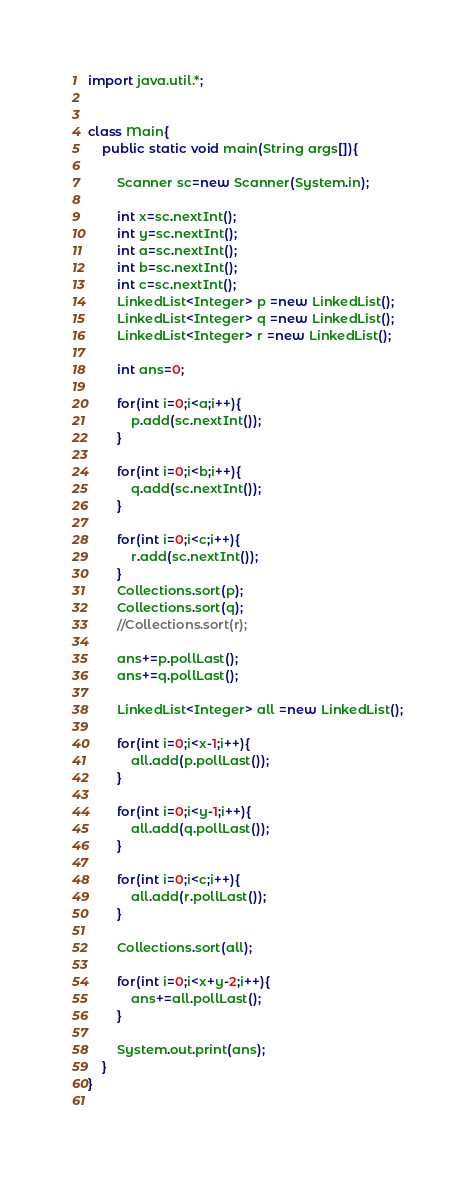<code> <loc_0><loc_0><loc_500><loc_500><_Java_>import java.util.*;


class Main{
	public static void main(String args[]){
		
		Scanner sc=new Scanner(System.in);
		
		int x=sc.nextInt();
		int y=sc.nextInt();
		int a=sc.nextInt();
		int b=sc.nextInt();
		int c=sc.nextInt();
		LinkedList<Integer> p =new LinkedList();
		LinkedList<Integer> q =new LinkedList();
		LinkedList<Integer> r =new LinkedList();
		
		int ans=0;
		
		for(int i=0;i<a;i++){
			p.add(sc.nextInt());
		}
		
		for(int i=0;i<b;i++){
			q.add(sc.nextInt());
		}
		
		for(int i=0;i<c;i++){
			r.add(sc.nextInt());
		}
		Collections.sort(p);
		Collections.sort(q);
		//Collections.sort(r);
		
		ans+=p.pollLast();
		ans+=q.pollLast();
		
		LinkedList<Integer> all =new LinkedList();
		
		for(int i=0;i<x-1;i++){
			all.add(p.pollLast());
		}
		
		for(int i=0;i<y-1;i++){
			all.add(q.pollLast());
		}
		
		for(int i=0;i<c;i++){
			all.add(r.pollLast());
		}
		
		Collections.sort(all);
		
		for(int i=0;i<x+y-2;i++){
			ans+=all.pollLast();
		}
		
		System.out.print(ans);
	}
}
	


</code> 